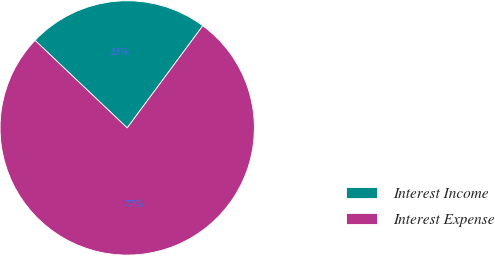Convert chart. <chart><loc_0><loc_0><loc_500><loc_500><pie_chart><fcel>Interest Income<fcel>Interest Expense<nl><fcel>23.05%<fcel>76.95%<nl></chart> 